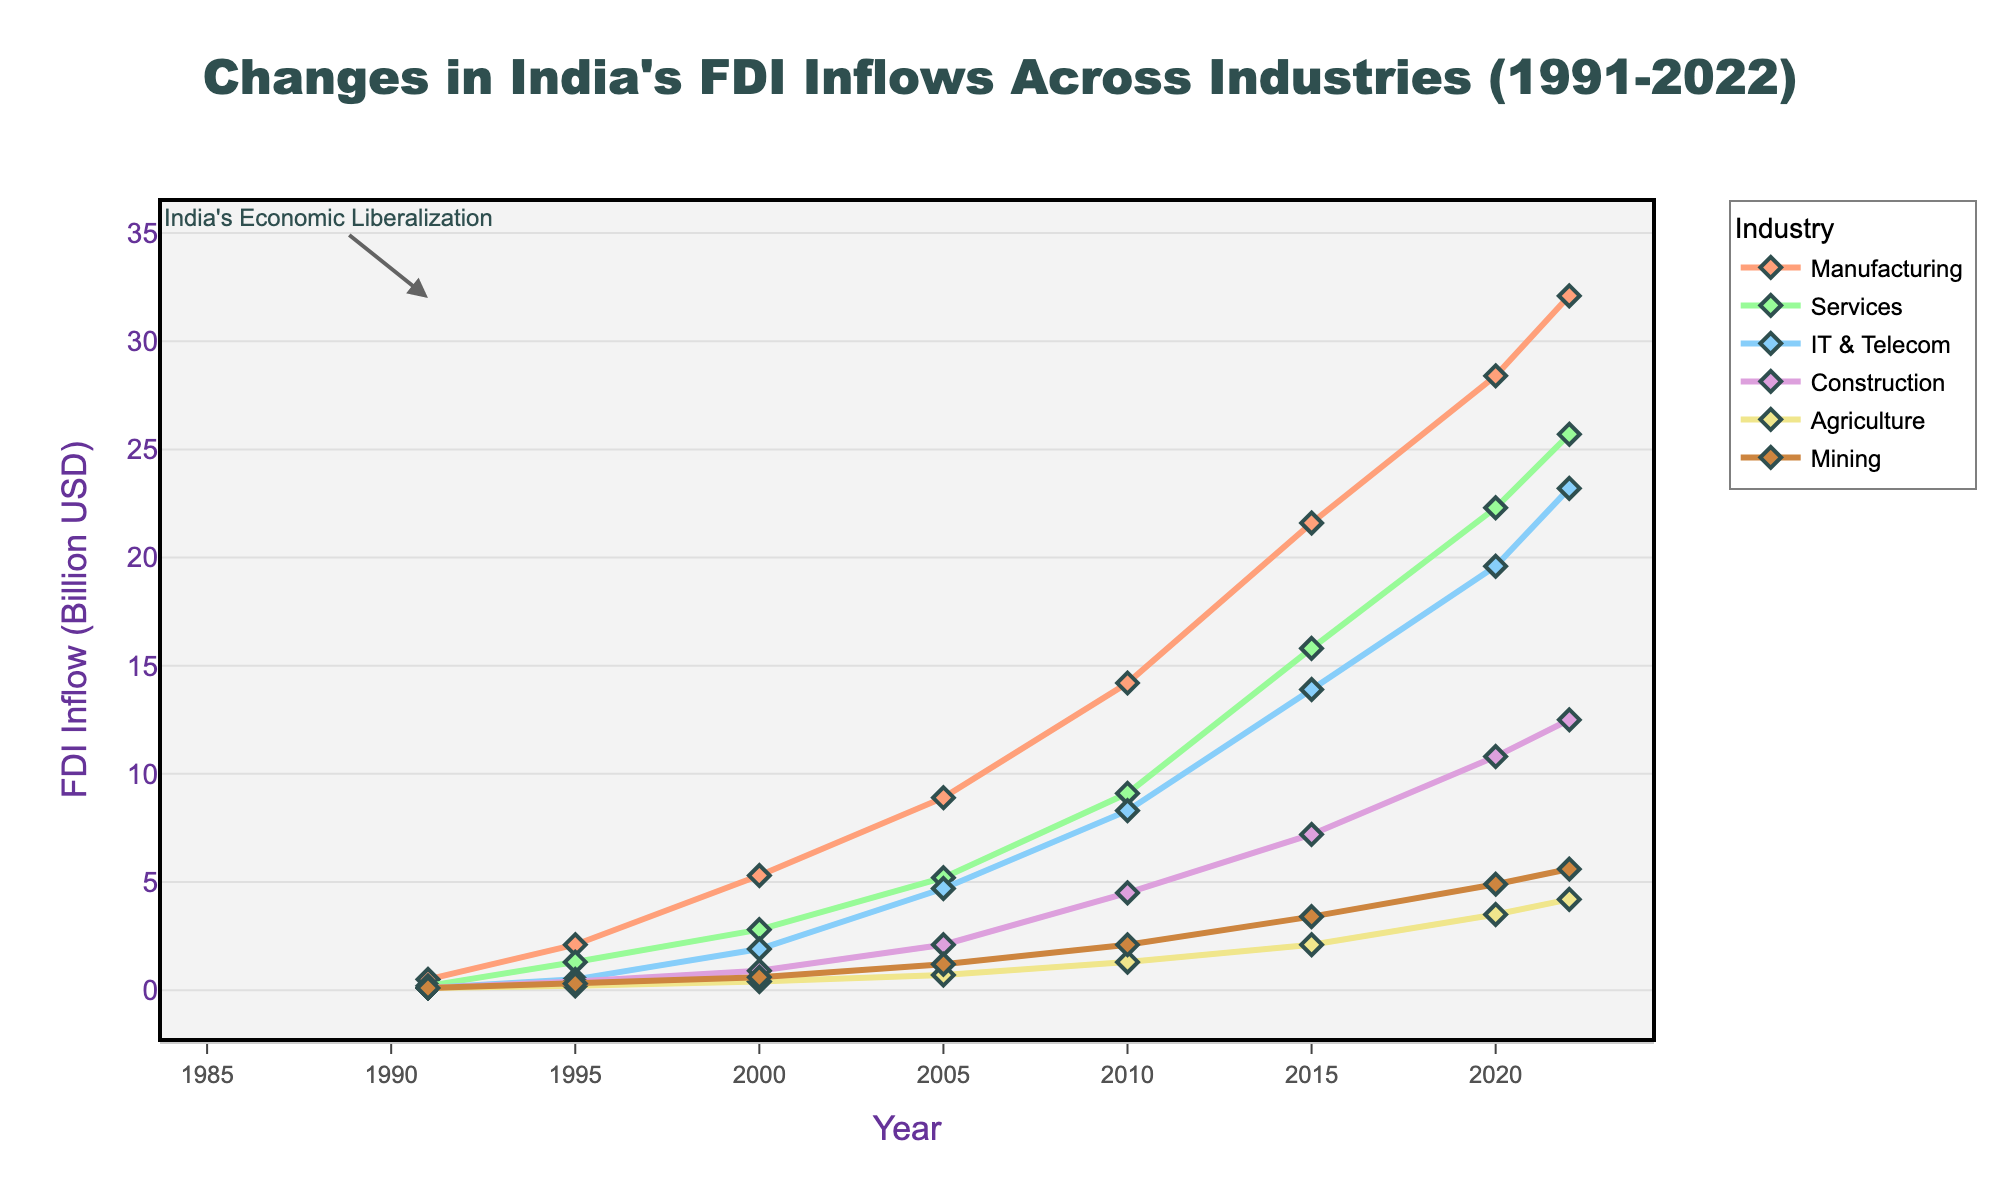What industry has seen the highest FDI inflow in the year 2022? By looking at the lines on the chart for the year 2022, you can identify the highest point among all industries. The manufacturing line reaches the highest point at around 32.1 billion USD.
Answer: Manufacturing Which industry had the lowest FDI inflow in 1995? For the year 1995, observe the lowest points of the lines. The agriculture industry line is the lowest, showing a value of 0.2 billion USD.
Answer: Agriculture How much did the FDI inflow in IT & Telecom change from 1991 to 2000? Locate the IT & Telecom line for the years 1991 and 2000, then subtract the FDI inflow in 1991 (0.1 billion USD) from the one in 2000 (1.9 billion USD). The change is 1.9 - 0.1 = 1.8 billion USD.
Answer: 1.8 billion USD Comparing the absolute growth, which industry had a larger increase in FDI inflow between 1995 and 2022: Services or Construction? Calculate the FDI inflow difference between 2022 and 1995 for each industry: Services increased from 1.3 billion USD to 25.7 billion USD (25.7 - 1.3 = 24.4 billion USD), and Construction increased from 0.4 billion USD to 12.5 billion USD (12.5 - 0.4 = 12.1 billion USD). Services had a larger absolute increase.
Answer: Services Which industry experienced the most steady growth in FDI inflows over the years? Visually inspect the smoothness and consistency of the lines without abrupt changes. The manufacturing line shows consistent upward growth without sharp fluctuations.
Answer: Manufacturing In which year did the mining industry first reach an FDI inflow of 2 billion USD? Follow the mining industry line until it reaches 2 billion USD; the line crosses 2 billion USD in 2010.
Answer: 2010 What is the average FDI inflow in the Agriculture industry from 1991 to 2022? Sum the agriculture FDI inflows over the years (0.1 + 0.2 + 0.4 + 0.7 + 1.3 + 2.1 + 3.5 + 4.2 = 12.5) and divide by the number of data points (8). The average is 12.5 / 8 = 1.56 billion USD.
Answer: 1.56 billion USD Which two industries had nearly similar FDI inflows in 2005? Observe the year 2005 and identify the industries with close FDI inflow values. IT & Telecom (4.7 billion USD) and Services (5.2 billion USD) have nearly similar inflows.
Answer: IT & Telecom and Services Has the construction industry's FDI inflow ever been higher than Services in any year? Compare the lines for Construction and Services each year. The Services industry has always been higher than Construction during the given time period.
Answer: No Which year did the agriculture industry see its greatest year-on-year growth in FDI inflow? Compare the year-on-year differences in FDI inflows for agriculture. The greatest increase is from 2005 to 2010 (1.3 billion USD - 0.7 billion USD = 0.6 billion USD).
Answer: 2010 